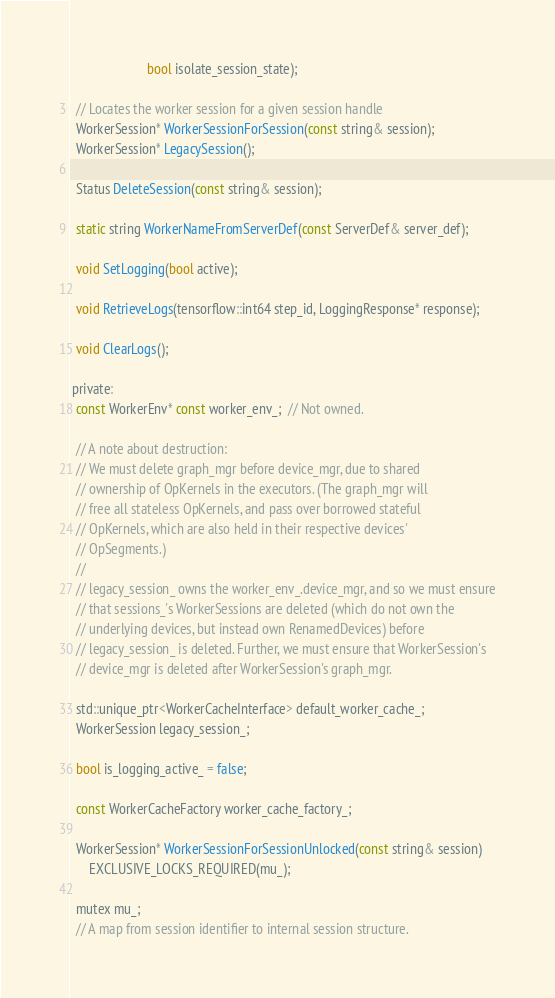<code> <loc_0><loc_0><loc_500><loc_500><_C_>                       bool isolate_session_state);

  // Locates the worker session for a given session handle
  WorkerSession* WorkerSessionForSession(const string& session);
  WorkerSession* LegacySession();

  Status DeleteSession(const string& session);

  static string WorkerNameFromServerDef(const ServerDef& server_def);

  void SetLogging(bool active);

  void RetrieveLogs(tensorflow::int64 step_id, LoggingResponse* response);

  void ClearLogs();

 private:
  const WorkerEnv* const worker_env_;  // Not owned.

  // A note about destruction:
  // We must delete graph_mgr before device_mgr, due to shared
  // ownership of OpKernels in the executors. (The graph_mgr will
  // free all stateless OpKernels, and pass over borrowed stateful
  // OpKernels, which are also held in their respective devices'
  // OpSegments.)
  //
  // legacy_session_ owns the worker_env_.device_mgr, and so we must ensure
  // that sessions_'s WorkerSessions are deleted (which do not own the
  // underlying devices, but instead own RenamedDevices) before
  // legacy_session_ is deleted. Further, we must ensure that WorkerSession's
  // device_mgr is deleted after WorkerSession's graph_mgr.

  std::unique_ptr<WorkerCacheInterface> default_worker_cache_;
  WorkerSession legacy_session_;

  bool is_logging_active_ = false;

  const WorkerCacheFactory worker_cache_factory_;

  WorkerSession* WorkerSessionForSessionUnlocked(const string& session)
      EXCLUSIVE_LOCKS_REQUIRED(mu_);

  mutex mu_;
  // A map from session identifier to internal session structure.</code> 